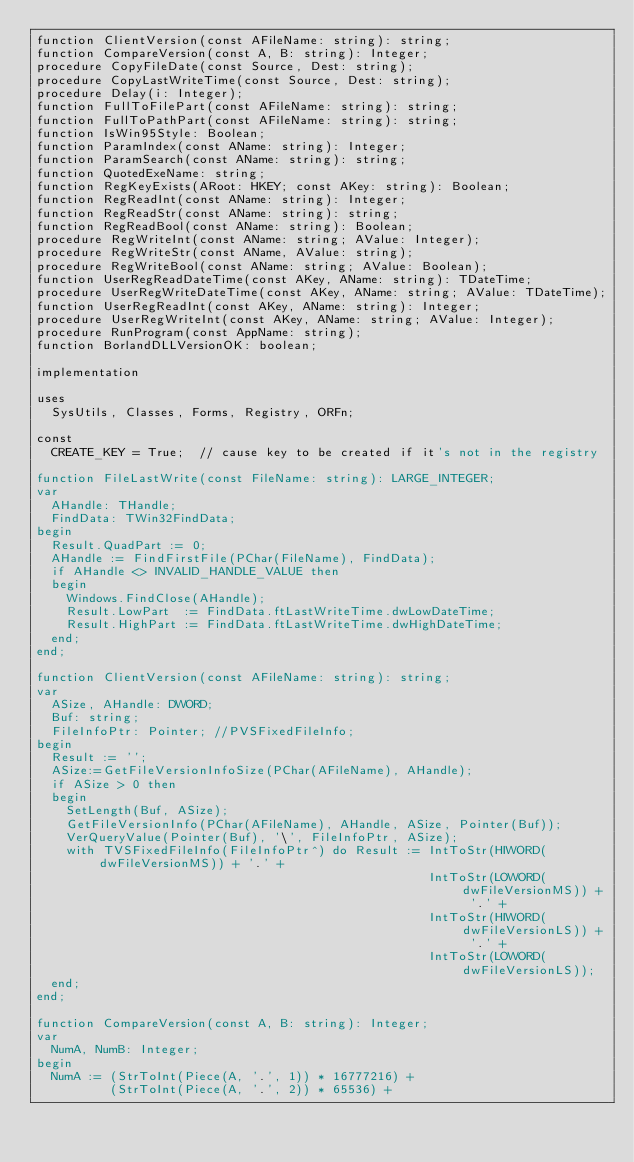Convert code to text. <code><loc_0><loc_0><loc_500><loc_500><_Pascal_>function ClientVersion(const AFileName: string): string;
function CompareVersion(const A, B: string): Integer;
procedure CopyFileDate(const Source, Dest: string);
procedure CopyLastWriteTime(const Source, Dest: string);
procedure Delay(i: Integer);
function FullToFilePart(const AFileName: string): string;
function FullToPathPart(const AFileName: string): string;
function IsWin95Style: Boolean;
function ParamIndex(const AName: string): Integer;
function ParamSearch(const AName: string): string;
function QuotedExeName: string;
function RegKeyExists(ARoot: HKEY; const AKey: string): Boolean;
function RegReadInt(const AName: string): Integer;
function RegReadStr(const AName: string): string;
function RegReadBool(const AName: string): Boolean;
procedure RegWriteInt(const AName: string; AValue: Integer);
procedure RegWriteStr(const AName, AValue: string);
procedure RegWriteBool(const AName: string; AValue: Boolean);
function UserRegReadDateTime(const AKey, AName: string): TDateTime;
procedure UserRegWriteDateTime(const AKey, AName: string; AValue: TDateTime);
function UserRegReadInt(const AKey, AName: string): Integer;
procedure UserRegWriteInt(const AKey, AName: string; AValue: Integer);
procedure RunProgram(const AppName: string);
function BorlandDLLVersionOK: boolean;

implementation

uses
  SysUtils, Classes, Forms, Registry, ORFn;

const
  CREATE_KEY = True;  // cause key to be created if it's not in the registry

function FileLastWrite(const FileName: string): LARGE_INTEGER;
var
  AHandle: THandle;
  FindData: TWin32FindData;
begin
  Result.QuadPart := 0;
  AHandle := FindFirstFile(PChar(FileName), FindData);
  if AHandle <> INVALID_HANDLE_VALUE then
  begin
    Windows.FindClose(AHandle);
    Result.LowPart  := FindData.ftLastWriteTime.dwLowDateTime;
    Result.HighPart := FindData.ftLastWriteTime.dwHighDateTime;
  end;
end;

function ClientVersion(const AFileName: string): string;
var
  ASize, AHandle: DWORD;
  Buf: string;
  FileInfoPtr: Pointer; //PVSFixedFileInfo;
begin
  Result := '';
  ASize:=GetFileVersionInfoSize(PChar(AFileName), AHandle);
  if ASize > 0 then
  begin
    SetLength(Buf, ASize);
    GetFileVersionInfo(PChar(AFileName), AHandle, ASize, Pointer(Buf));
    VerQueryValue(Pointer(Buf), '\', FileInfoPtr, ASize);
    with TVSFixedFileInfo(FileInfoPtr^) do Result := IntToStr(HIWORD(dwFileVersionMS)) + '.' +
                                                     IntToStr(LOWORD(dwFileVersionMS)) + '.' +
                                                     IntToStr(HIWORD(dwFileVersionLS)) + '.' +
                                                     IntToStr(LOWORD(dwFileVersionLS));
  end;
end;

function CompareVersion(const A, B: string): Integer;
var
  NumA, NumB: Integer;
begin
  NumA := (StrToInt(Piece(A, '.', 1)) * 16777216) +
          (StrToInt(Piece(A, '.', 2)) * 65536) +</code> 